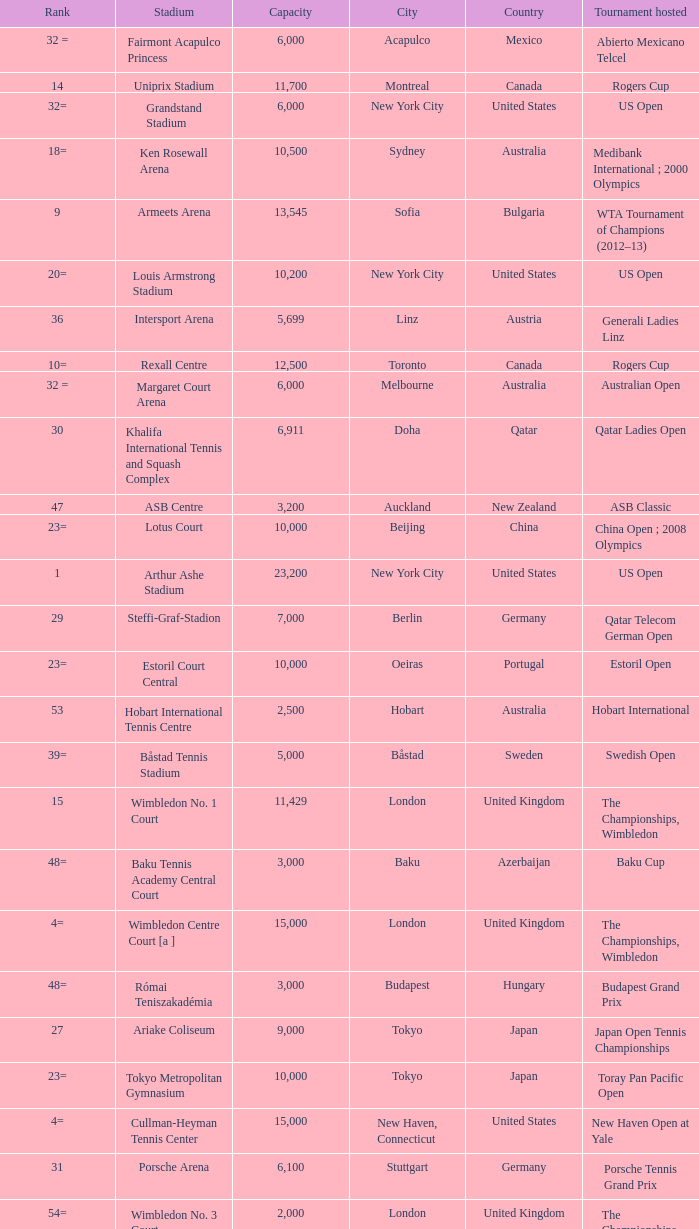Give me the full table as a dictionary. {'header': ['Rank', 'Stadium', 'Capacity', 'City', 'Country', 'Tournament hosted'], 'rows': [['32 =', 'Fairmont Acapulco Princess', '6,000', 'Acapulco', 'Mexico', 'Abierto Mexicano Telcel'], ['14', 'Uniprix Stadium', '11,700', 'Montreal', 'Canada', 'Rogers Cup'], ['32=', 'Grandstand Stadium', '6,000', 'New York City', 'United States', 'US Open'], ['18=', 'Ken Rosewall Arena', '10,500', 'Sydney', 'Australia', 'Medibank International ; 2000 Olympics'], ['9', 'Armeets Arena', '13,545', 'Sofia', 'Bulgaria', 'WTA Tournament of Champions (2012–13)'], ['20=', 'Louis Armstrong Stadium', '10,200', 'New York City', 'United States', 'US Open'], ['36', 'Intersport Arena', '5,699', 'Linz', 'Austria', 'Generali Ladies Linz'], ['10=', 'Rexall Centre', '12,500', 'Toronto', 'Canada', 'Rogers Cup'], ['32 =', 'Margaret Court Arena', '6,000', 'Melbourne', 'Australia', 'Australian Open'], ['30', 'Khalifa International Tennis and Squash Complex', '6,911', 'Doha', 'Qatar', 'Qatar Ladies Open'], ['47', 'ASB Centre', '3,200', 'Auckland', 'New Zealand', 'ASB Classic'], ['23=', 'Lotus Court', '10,000', 'Beijing', 'China', 'China Open ; 2008 Olympics'], ['1', 'Arthur Ashe Stadium', '23,200', 'New York City', 'United States', 'US Open'], ['29', 'Steffi-Graf-Stadion', '7,000', 'Berlin', 'Germany', 'Qatar Telecom German Open'], ['23=', 'Estoril Court Central', '10,000', 'Oeiras', 'Portugal', 'Estoril Open'], ['53', 'Hobart International Tennis Centre', '2,500', 'Hobart', 'Australia', 'Hobart International'], ['39=', 'Båstad Tennis Stadium', '5,000', 'Båstad', 'Sweden', 'Swedish Open'], ['15', 'Wimbledon No. 1 Court', '11,429', 'London', 'United Kingdom', 'The Championships, Wimbledon'], ['48=', 'Baku Tennis Academy Central Court', '3,000', 'Baku', 'Azerbaijan', 'Baku Cup'], ['4=', 'Wimbledon Centre Court [a ]', '15,000', 'London', 'United Kingdom', 'The Championships, Wimbledon'], ['48=', 'Római Teniszakadémia', '3,000', 'Budapest', 'Hungary', 'Budapest Grand Prix'], ['27', 'Ariake Coliseum', '9,000', 'Tokyo', 'Japan', 'Japan Open Tennis Championships'], ['23=', 'Tokyo Metropolitan Gymnasium', '10,000', 'Tokyo', 'Japan', 'Toray Pan Pacific Open'], ['4=', 'Cullman-Heyman Tennis Center', '15,000', 'New Haven, Connecticut', 'United States', 'New Haven Open at Yale'], ['31', 'Porsche Arena', '6,100', 'Stuttgart', 'Germany', 'Porsche Tennis Grand Prix'], ['54=', 'Wimbledon No. 3 Court', '2,000', 'London', 'United Kingdom', 'The Championships, Wimbledon'], ['32=', 'Roy Emerson Arena', '6,000', 'Gstaad', 'Switzerland', 'Allianz Suisse Open Gstaad'], ['54=', 'National Tennis Center Court 1', '2,000', 'Beijing', 'China', 'China Open'], ['20=', 'Family Circle Tennis Center', '10,200', 'Charleston, South Carolina', 'United States', 'Family Circle Cup'], ['10=', 'Caja Mágica, Estadio Manolo Santana', '12,500', 'Madrid', 'Spain', 'Madrid Masters'], ['10=', 'Foro Italico, Campo Centrale', '12,500', 'Rome', 'Italy', "Internazionali d'Italia"], ['46', 'Darling Tennis Center', '3,500', 'Las Vegas, Nevada', 'United States', 'Tennis Channel Open'], ['2', 'Sinan Erdem Dome', '16,410', 'Istanbul', 'Turkey', 'WTA Championships'], ['37', 'Pat Rafter Arena', '5,500', 'Brisbane', 'Australia', 'Brisbane International'], ['22', 'Stade Roland Garros - Court Suzanne Lenglen', '10,076', 'Paris', 'France', 'French Open'], ['7', 'Stade Roland Garros - Court Philippe Chatrier', '14,911', 'Paris', 'France', 'French Open'], ['8', 'Rod Laver Arena', '14,820', 'Melbourne', 'Australia', 'Australian Open'], ['4=', 'National Tennis Stadium', '15,000', 'Beijing', 'China', 'China Open ; 2008 Olympics'], ['48=', 'Australia Show Court 2', '3,000', 'Melbourne', 'Australia', 'Australian Open'], ['39=', 'Guangzhou International Tennis Center', '5,000', 'Guangzhou', 'China', "Guangzhou International Women's Open"], ['16=', 'Lindner Family Tennis Center', '11,400', 'Mason, Ohio', 'United States', 'W&SFG Masters'], ['28', 'Devonshire Park Lawn Tennis Club', '8,000', 'Eastbourne', 'United Kingdom', 'Eastbourne International'], ['39=', 'Kungliga Tennishallen', '5,000', 'Stockholm', 'Sweden', 'Stockholm Open'], ['48=', 'Court 17', '3,000', 'New York', 'United States', 'US Open'], ['38', 'Racquet Club of Memphis', '5,200', 'Memphis, Tennessee', 'United States', 'Cellular South Cup'], ['43=', 'Wimbledon No. 2 Court', '4,000', 'London', 'United Kingdom', 'The Championships, Wimbledon'], ['16=', 'Olympic Stadium', '11,400', 'Moscow', 'Russia', 'Kremlin Cup'], ['39=', 'Dubai Tennis Stadium', '5,000', 'Dubai', 'United Arab Emirates', 'Dubai Tennis Championships'], ['39=', 'Sportlokaal Bokkeduinen', '5,000', 'Amersfoort', 'Netherlands', 'Dutch Open Amersfoort'], ['13', 'Petersburg Sports and Concert Complex', '12,000', 'St. Petersburg', 'Russia', 'St. Petersburg Open'], ['23=', 'Seoul Olympic Park Tennis Center', '10,000', 'Seoul', 'South Korea', '1988 Olympics ; Hansol Korea Open'], ['48=', 'Australia Show Court 3', '3,000', 'Melbourne', 'Australia', 'Australian Open'], ['10', 'Tennis Center at Crandon Park', '13,300', 'Key Biscayne, Florida', 'United States', 'Sony Ericsson Open'], ['45', 'Roland Garros No. 1 Court', '3,805', 'Paris', 'France', 'French Open'], ['43=', 'Moon Court', '4,000', 'Beijing', 'China', 'China Open'], ['3', 'Indian Wells Tennis Garden', '16,100', 'Indian Wells, California', 'United States', 'BNP Paribas Open'], ['18=', 'Hisense Arena', '10,500', 'Melbourne', 'Australia', 'Australian Open']]} What is the average capacity that has rod laver arena as the stadium? 14820.0. 